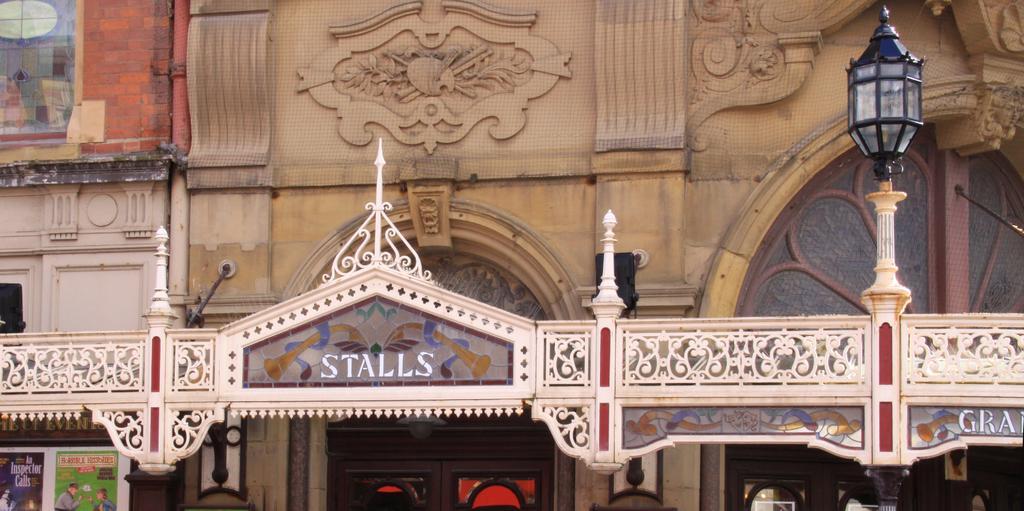How would you summarize this image in a sentence or two? In this image I can see the building. To the right I can see the light pole. I can see the boards and windows to the building. 